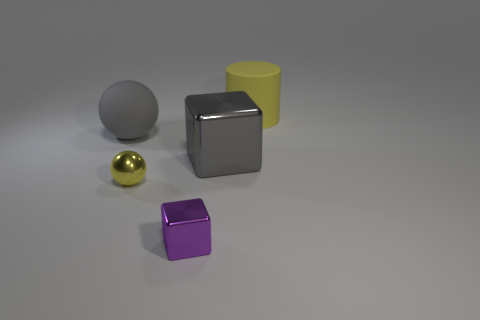What could you infer about the lighting used in the scene? The lighting in this scene seems to be soft and diffused, as indicated by the gentle shadows and subtle highlights on the objects. There are no harsh shadows or strong contrasts, suggesting that the light source is either large or placed at a significant distance from the objects. Could there be multiple light sources in this scene? It's possible there are multiple light sources. While there's a primary light creating the shadows to the right of the objects, there might be secondary, softer lights to reduce the scene's overall contrast and fill in the shadows, which would give the image a more evenly lit appearance. 